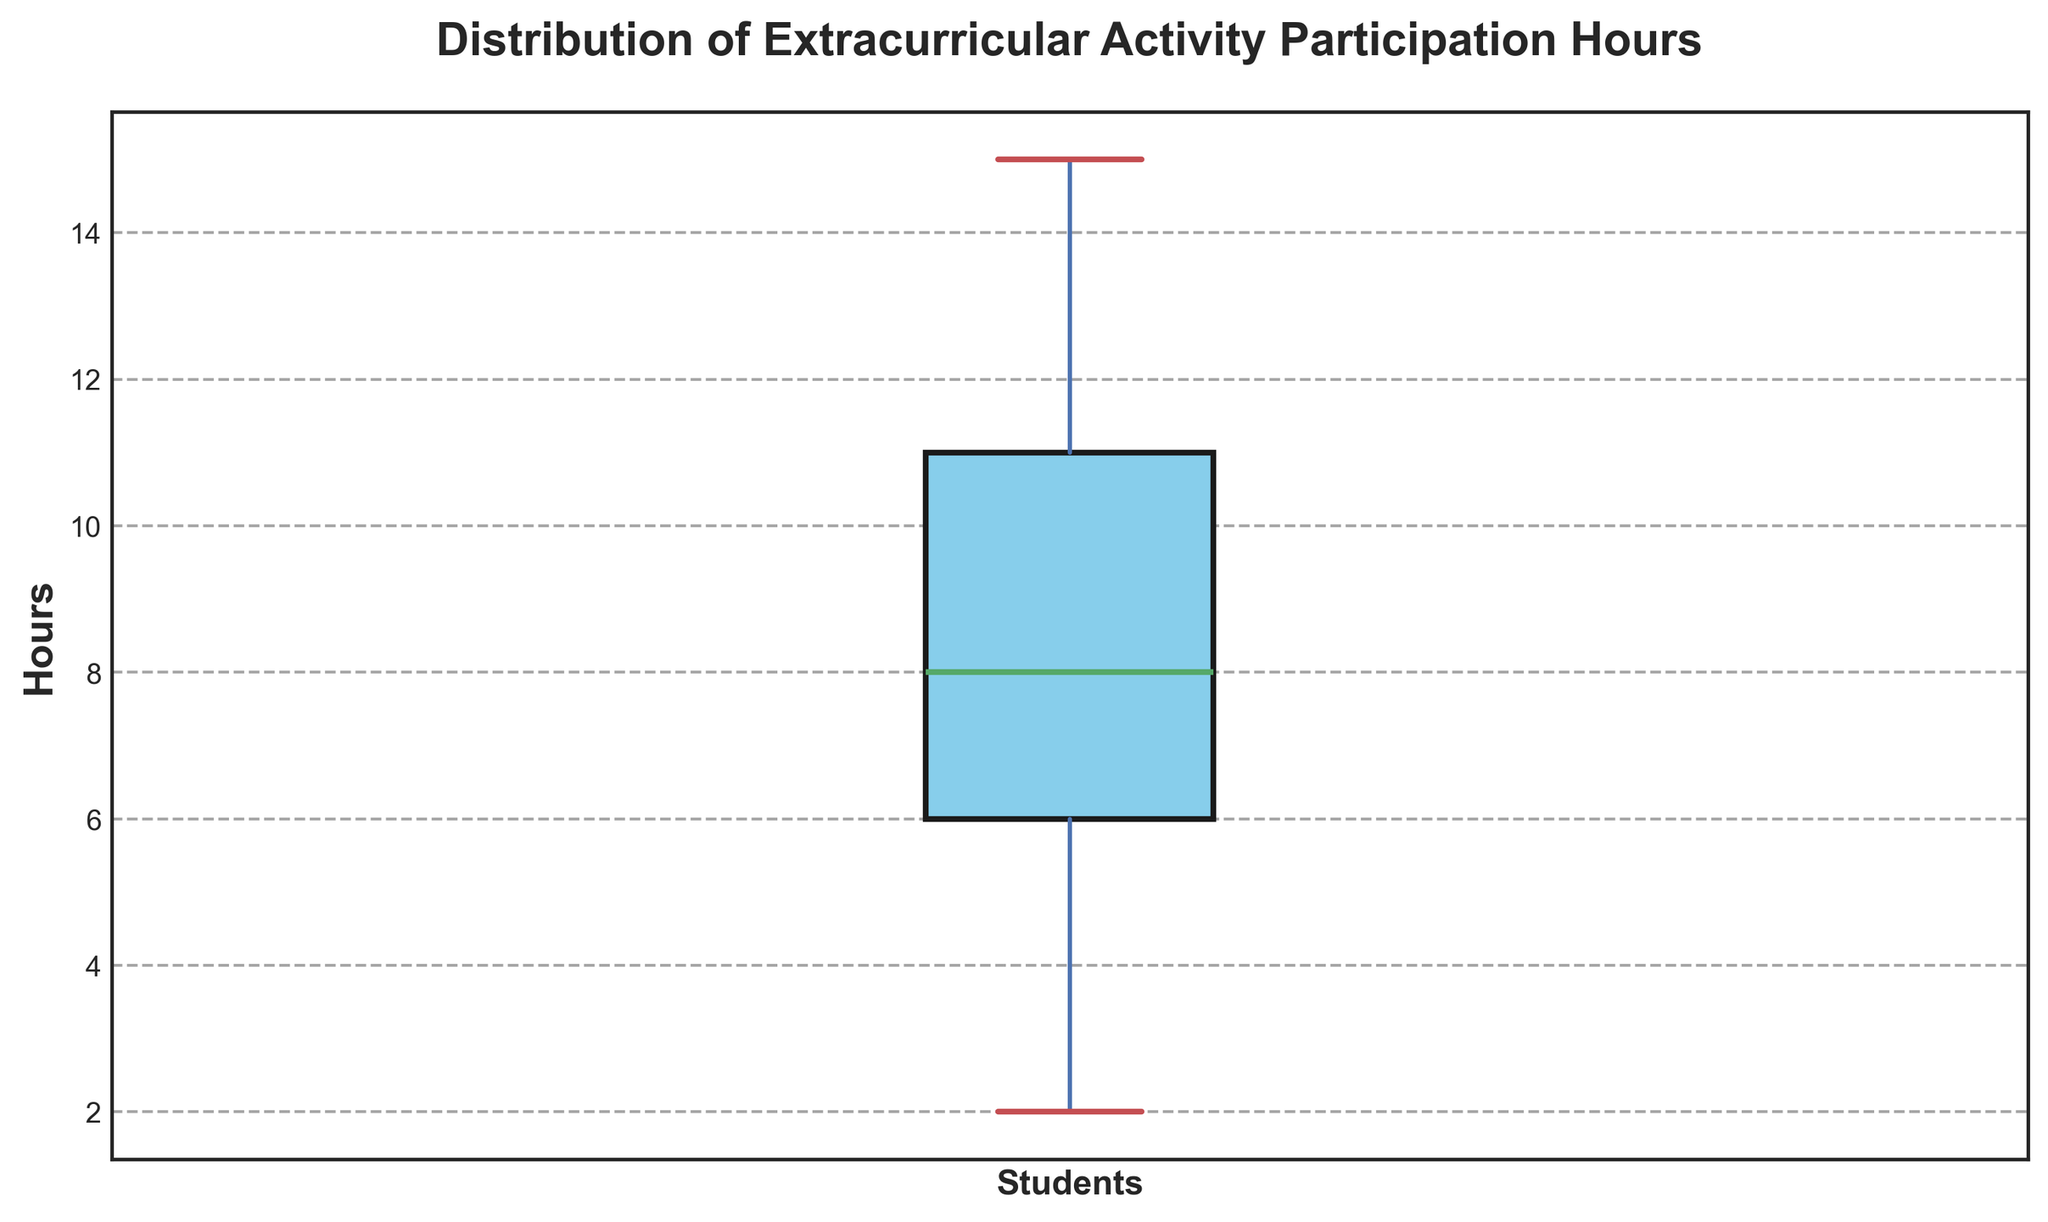what is the median value of activity participation hours? To find the median value of the activity participation hours, we look at the box plot's horizontal line inside the box, which represents the median. The median is the middle value that separates the higher half from the lower half of data.
Answer: 8 What is the interquartile range (IQR) of activity participation hours? The Interquartile Range (IQR) is the difference between the upper quartile (75th percentile) and the lower quartile (25th percentile). These quartiles are represented by the edges of the box.
Answer: 8 How many hours do the students in the lower quartile participate in extracurricular activities? Students in the lower quartile (25th percentile) participate in extracurricular activities for the number of hours represented by the lower edge of the box.
Answer: 5 What is the maximum number of hours students participate in extracurricular activities, excluding outliers? The maximum number of hours, excluding outliers, is indicated by the top whisker.
Answer: 15 Identify any potential outliers in the dataset and their participation hours. Outliers are points that lie outside the whiskers. These can be identified by looking for individual points that are separate from the main data.
Answer: None What is the range of activity participation hours? The range is the difference between the maximum and minimum values, indicated by the tips of the whiskers.
Answer: 2 to 15 Compare the median activity participation hours and the mean (average) value based on visual approximation. Which is higher? The median is represented by the horizontal line in the box plot, while the mean would generally be located around this line if the data is symmetric. By estimating, we can compare these values.
Answer: Median is approximately 8; Mean is likely close but can vary slightly, approximation needed Which quartile has the most variability in activity participation hours? The variability within a quartile can be observed by the width of the box plot segment representing that quartile. The larger the segment, the more variability.
Answer: The lower quartile (bottom 25%) appears to have more variability as its segment seems wider How do the whiskers' lengths compare above and below the box? What can this indicate about the distribution of the data? The lengths of the whiskers can be compared to see if one is significantly longer than the other, indicating skewness.
Answer: The upper whisker is longer, indicating positive/right skewness Describe the shape of the distribution based on the box plot. Is it skewed? If yes, in which direction? Skewness is deduced from the relative lengths of the whiskers and the position of the median. If the upper whisker is longer and the median is closer to the lower quartile, it indicates right skewness.
Answer: Right skewed 